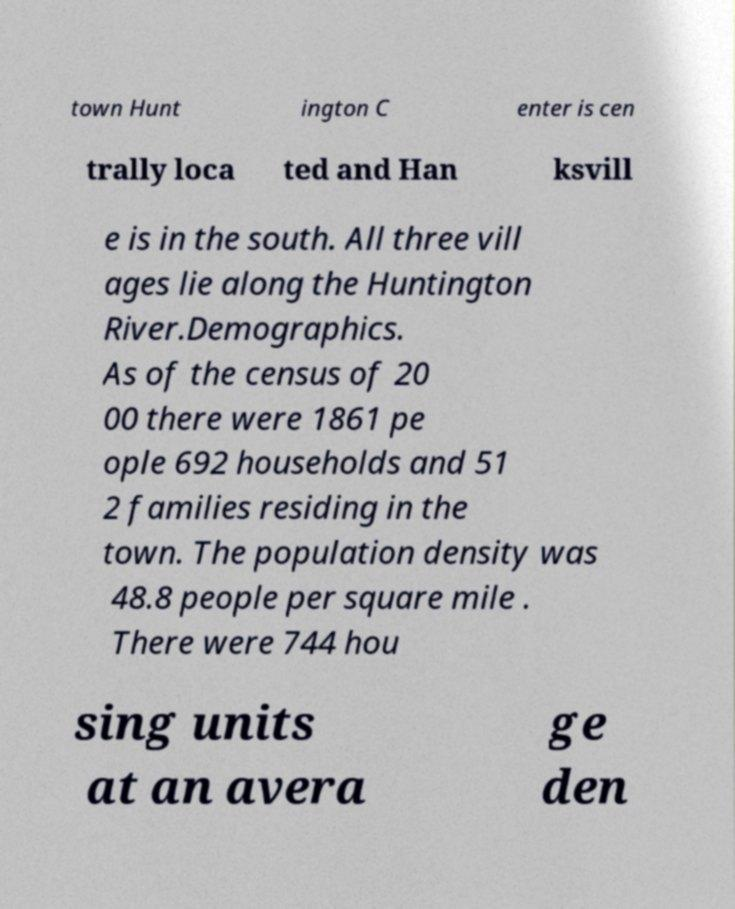Could you extract and type out the text from this image? town Hunt ington C enter is cen trally loca ted and Han ksvill e is in the south. All three vill ages lie along the Huntington River.Demographics. As of the census of 20 00 there were 1861 pe ople 692 households and 51 2 families residing in the town. The population density was 48.8 people per square mile . There were 744 hou sing units at an avera ge den 